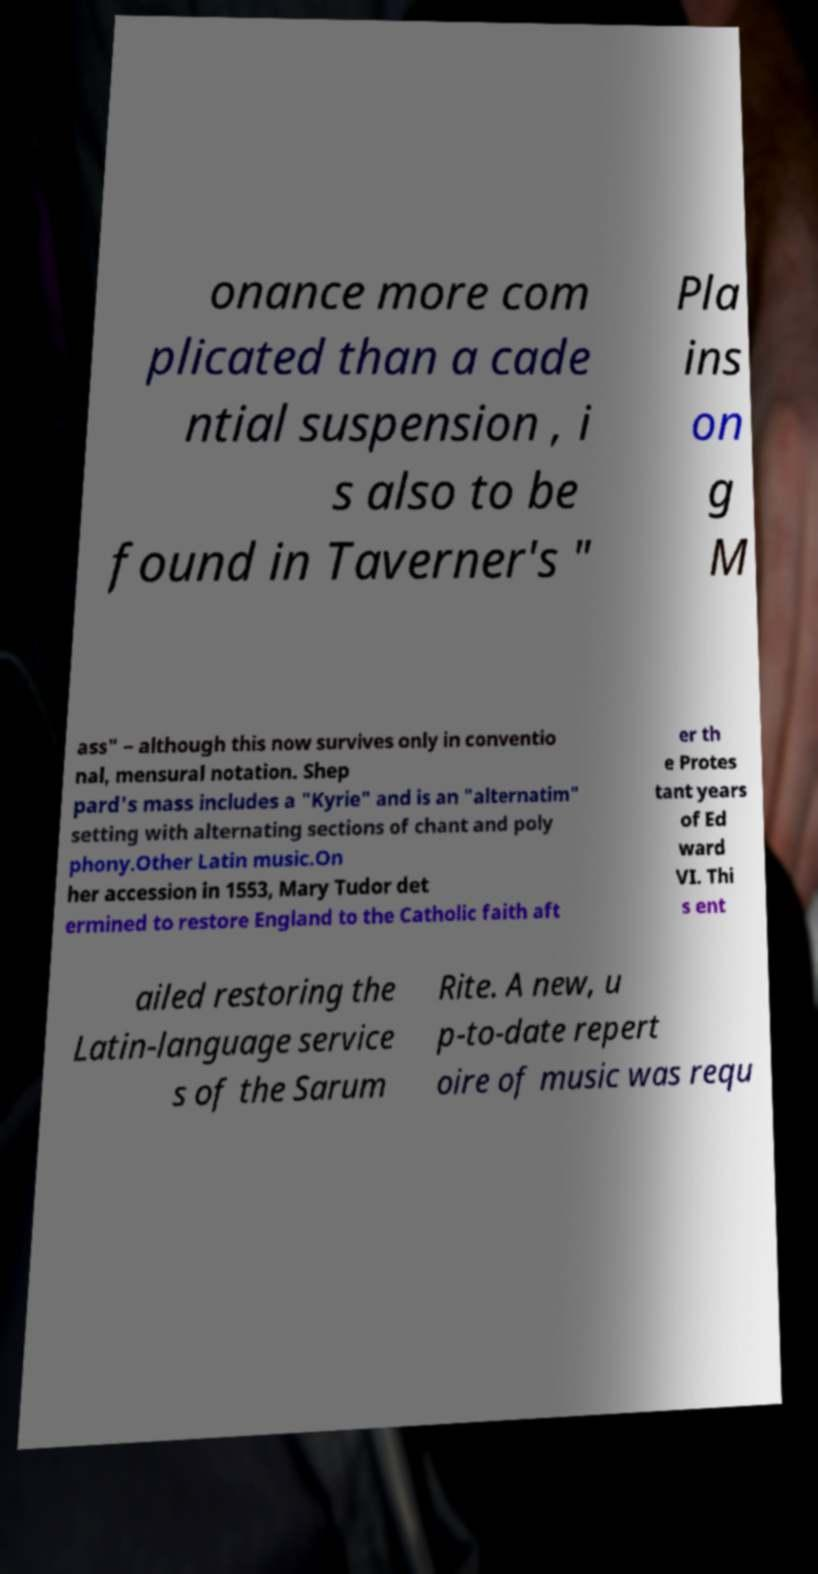For documentation purposes, I need the text within this image transcribed. Could you provide that? onance more com plicated than a cade ntial suspension , i s also to be found in Taverner's " Pla ins on g M ass" – although this now survives only in conventio nal, mensural notation. Shep pard's mass includes a "Kyrie" and is an "alternatim" setting with alternating sections of chant and poly phony.Other Latin music.On her accession in 1553, Mary Tudor det ermined to restore England to the Catholic faith aft er th e Protes tant years of Ed ward VI. Thi s ent ailed restoring the Latin-language service s of the Sarum Rite. A new, u p-to-date repert oire of music was requ 